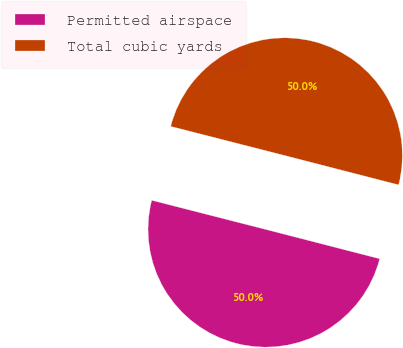Convert chart. <chart><loc_0><loc_0><loc_500><loc_500><pie_chart><fcel>Permitted airspace<fcel>Total cubic yards<nl><fcel>49.97%<fcel>50.03%<nl></chart> 